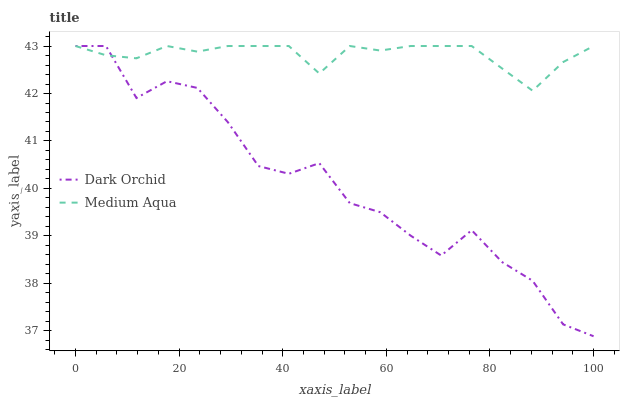Does Dark Orchid have the minimum area under the curve?
Answer yes or no. Yes. Does Medium Aqua have the maximum area under the curve?
Answer yes or no. Yes. Does Dark Orchid have the maximum area under the curve?
Answer yes or no. No. Is Medium Aqua the smoothest?
Answer yes or no. Yes. Is Dark Orchid the roughest?
Answer yes or no. Yes. Is Dark Orchid the smoothest?
Answer yes or no. No. Does Dark Orchid have the lowest value?
Answer yes or no. Yes. Does Dark Orchid have the highest value?
Answer yes or no. Yes. Does Dark Orchid intersect Medium Aqua?
Answer yes or no. Yes. Is Dark Orchid less than Medium Aqua?
Answer yes or no. No. Is Dark Orchid greater than Medium Aqua?
Answer yes or no. No. 